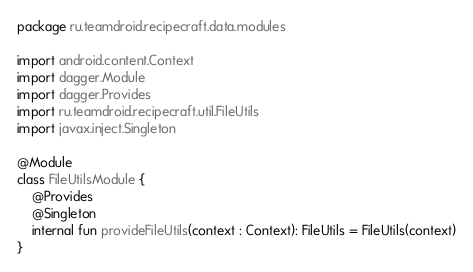Convert code to text. <code><loc_0><loc_0><loc_500><loc_500><_Kotlin_>package ru.teamdroid.recipecraft.data.modules

import android.content.Context
import dagger.Module
import dagger.Provides
import ru.teamdroid.recipecraft.util.FileUtils
import javax.inject.Singleton

@Module
class FileUtilsModule {
    @Provides
    @Singleton
    internal fun provideFileUtils(context : Context): FileUtils = FileUtils(context)
}</code> 